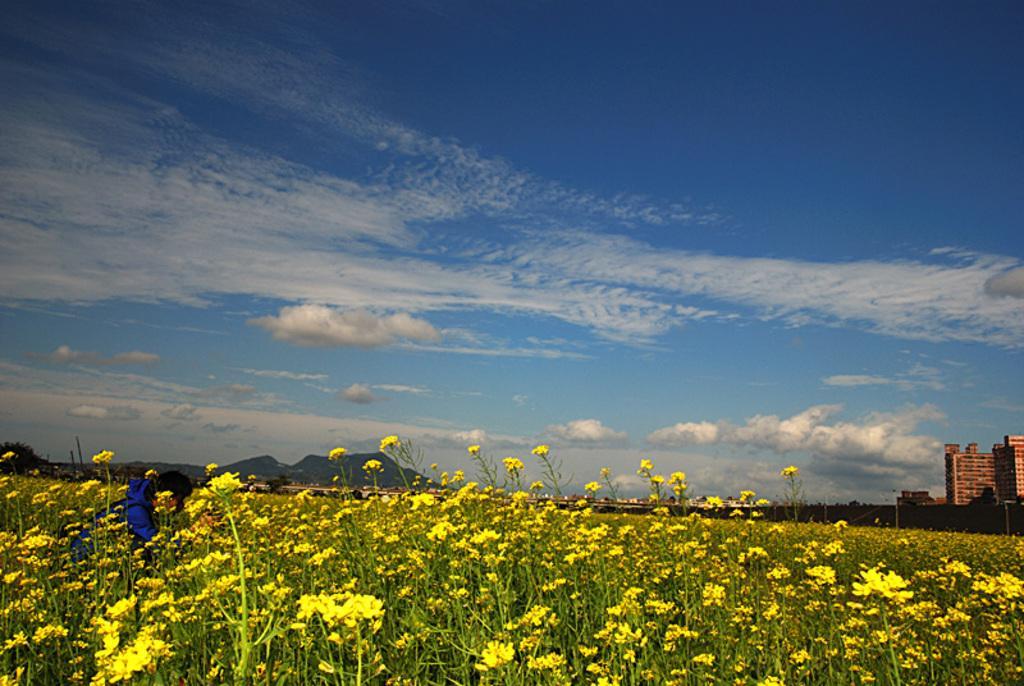Please provide a concise description of this image. In this image we can see few yellow flowers, in the background of the image we can see mountains and buildings, at the top of the image in the sky we can see clouds. 